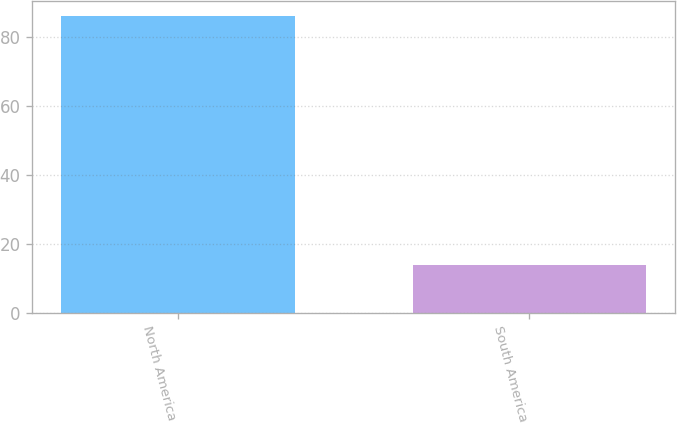Convert chart to OTSL. <chart><loc_0><loc_0><loc_500><loc_500><bar_chart><fcel>North America<fcel>South America<nl><fcel>86<fcel>14<nl></chart> 